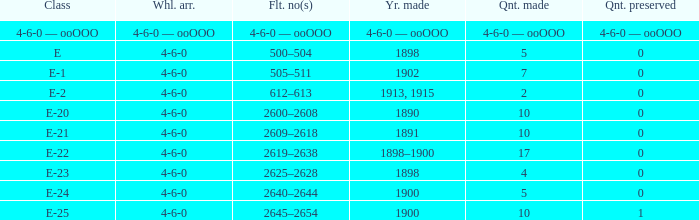What is the fleet number with a 4-6-0 wheel arrangement made in 1890? 2600–2608. 